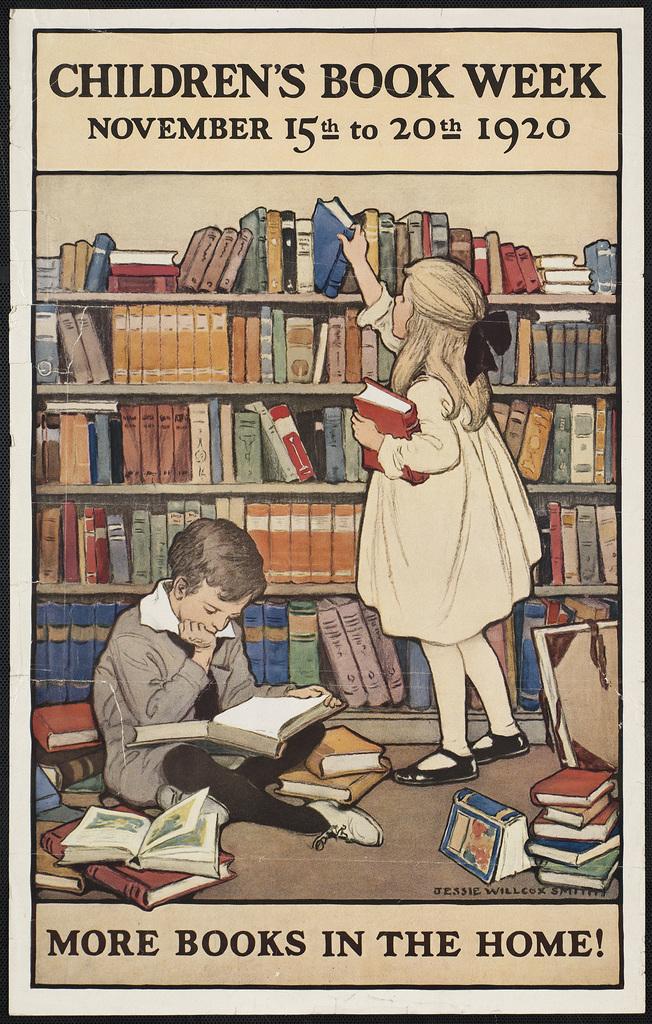When was children's book week in 1920?
Offer a very short reply. November 15th to 20th. What is the slogan on the sign?
Keep it short and to the point. More books in the home!. 